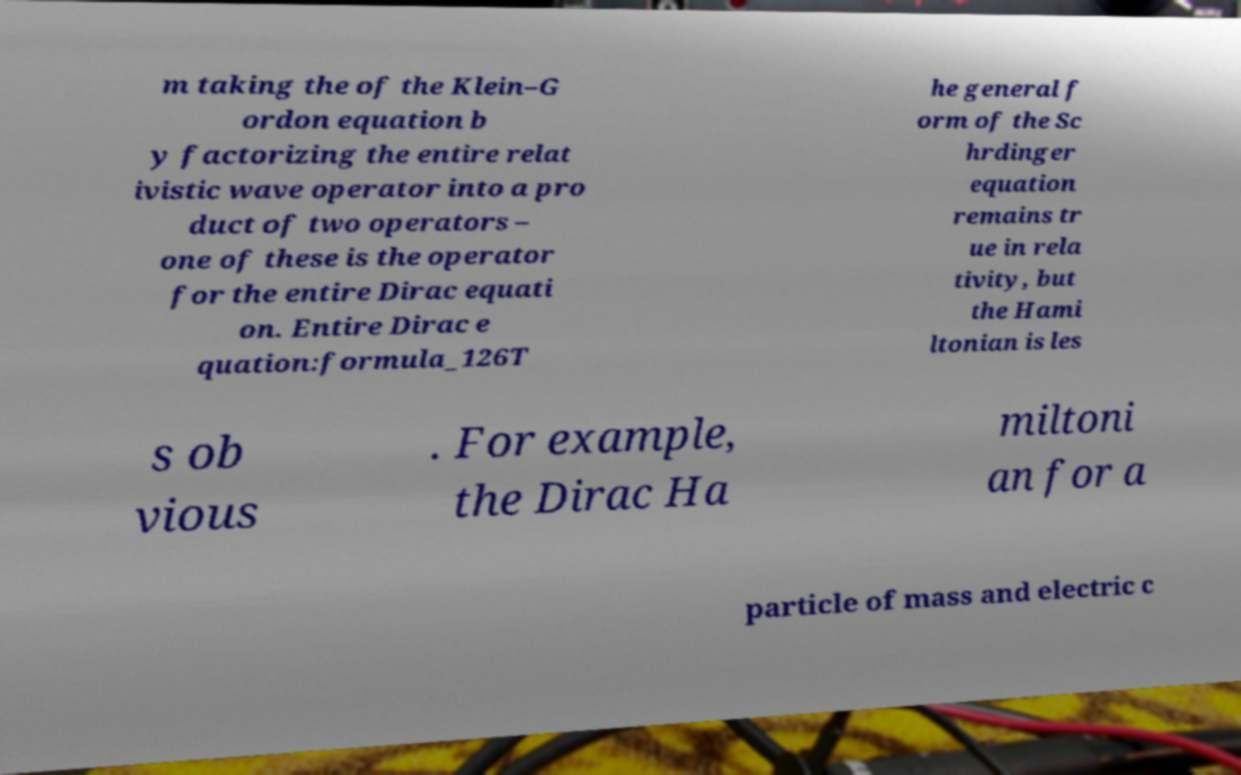Could you assist in decoding the text presented in this image and type it out clearly? m taking the of the Klein–G ordon equation b y factorizing the entire relat ivistic wave operator into a pro duct of two operators – one of these is the operator for the entire Dirac equati on. Entire Dirac e quation:formula_126T he general f orm of the Sc hrdinger equation remains tr ue in rela tivity, but the Hami ltonian is les s ob vious . For example, the Dirac Ha miltoni an for a particle of mass and electric c 